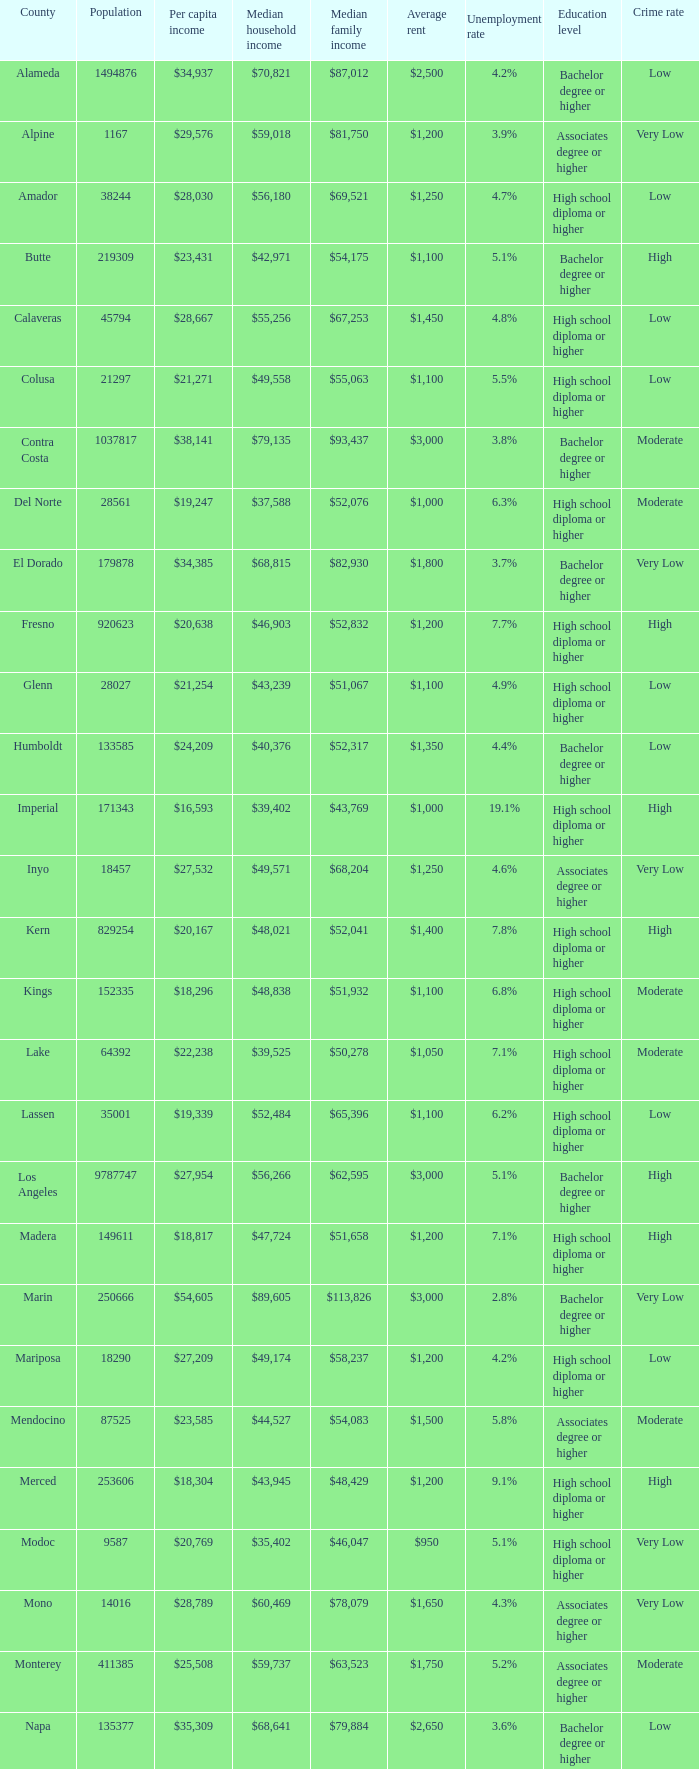What is shasta's income per capita? $23,691. 